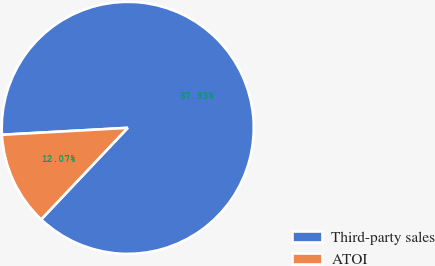Convert chart to OTSL. <chart><loc_0><loc_0><loc_500><loc_500><pie_chart><fcel>Third-party sales<fcel>ATOI<nl><fcel>87.93%<fcel>12.07%<nl></chart> 